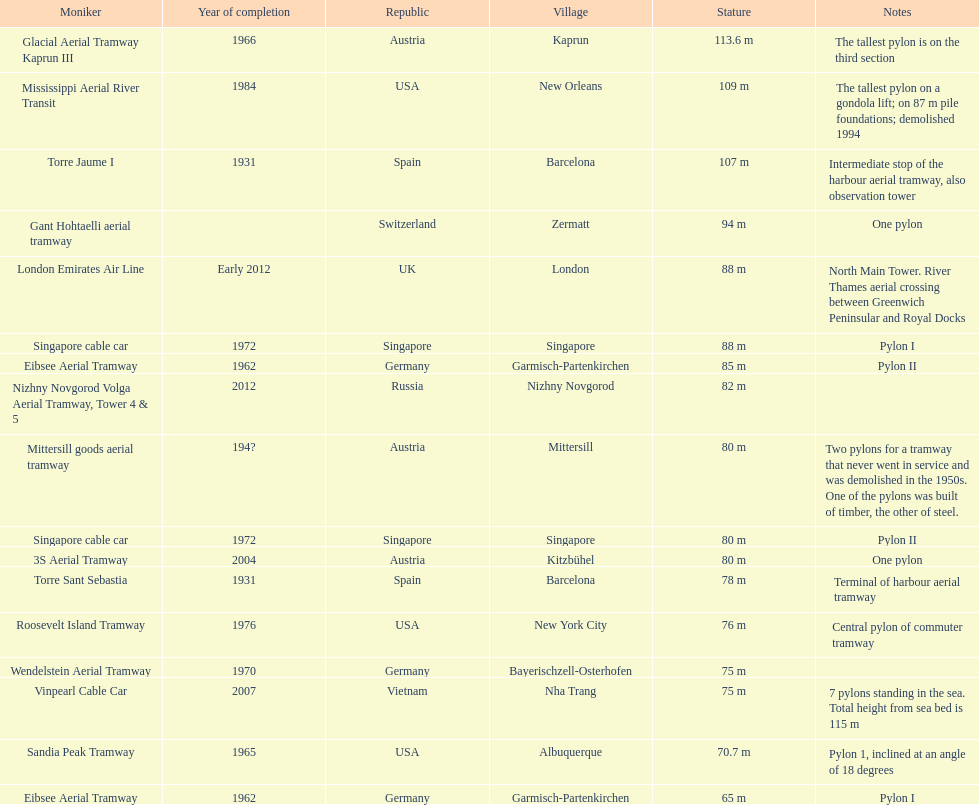What is the pylon with the least height listed here? Eibsee Aerial Tramway. 